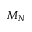<formula> <loc_0><loc_0><loc_500><loc_500>M _ { N }</formula> 